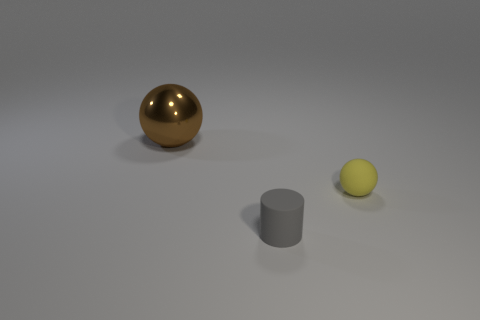Add 3 big yellow cubes. How many objects exist? 6 Subtract all cylinders. How many objects are left? 2 Add 1 small cylinders. How many small cylinders are left? 2 Add 3 big spheres. How many big spheres exist? 4 Subtract 0 cyan cubes. How many objects are left? 3 Subtract all yellow things. Subtract all large balls. How many objects are left? 1 